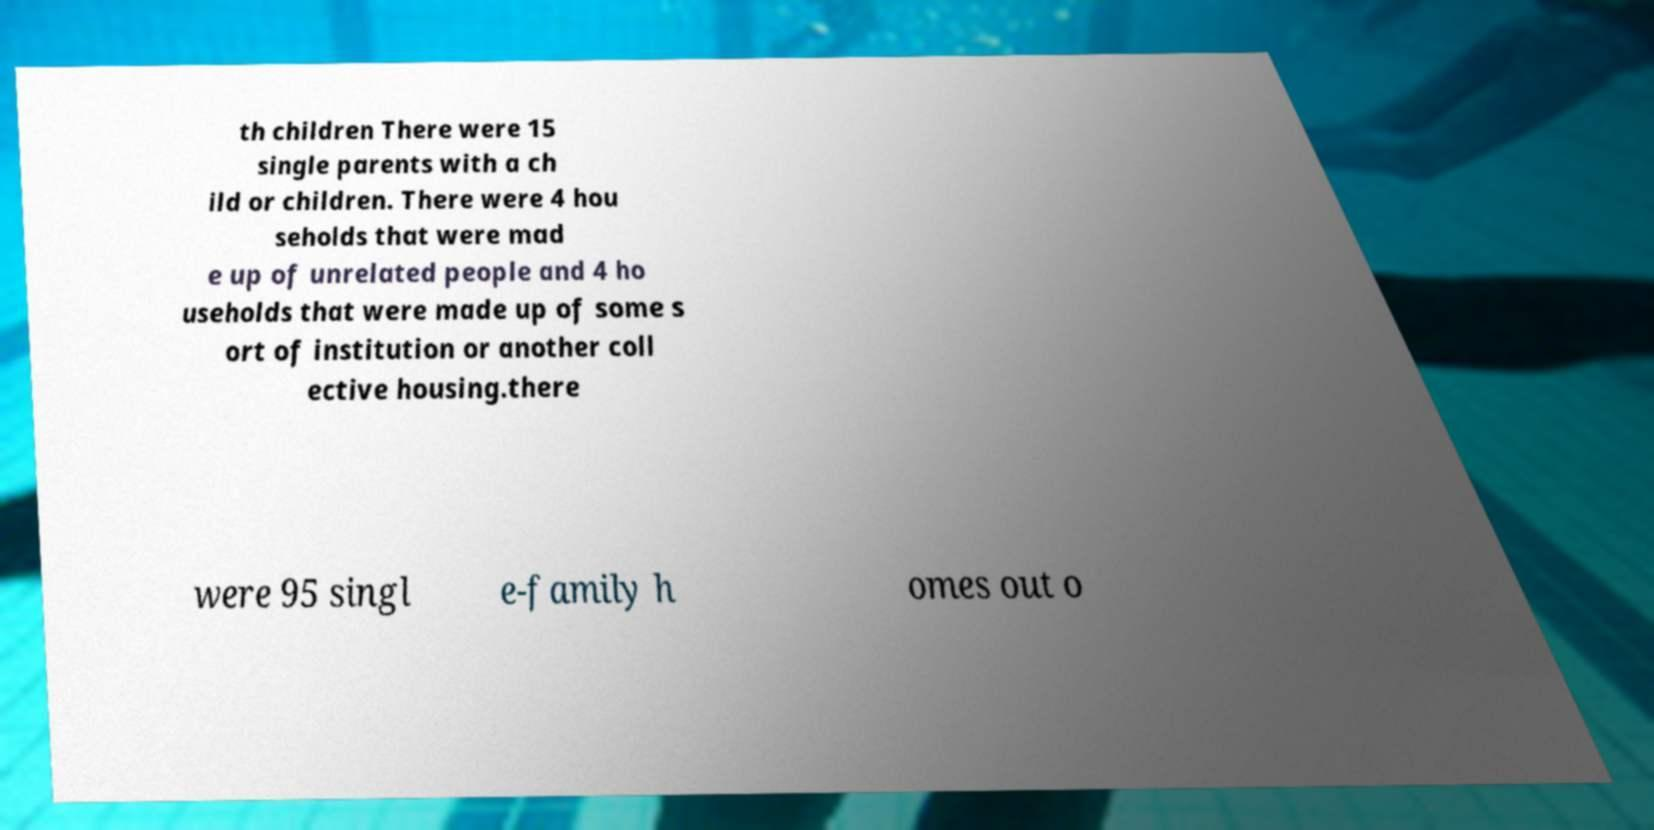What messages or text are displayed in this image? I need them in a readable, typed format. th children There were 15 single parents with a ch ild or children. There were 4 hou seholds that were mad e up of unrelated people and 4 ho useholds that were made up of some s ort of institution or another coll ective housing.there were 95 singl e-family h omes out o 